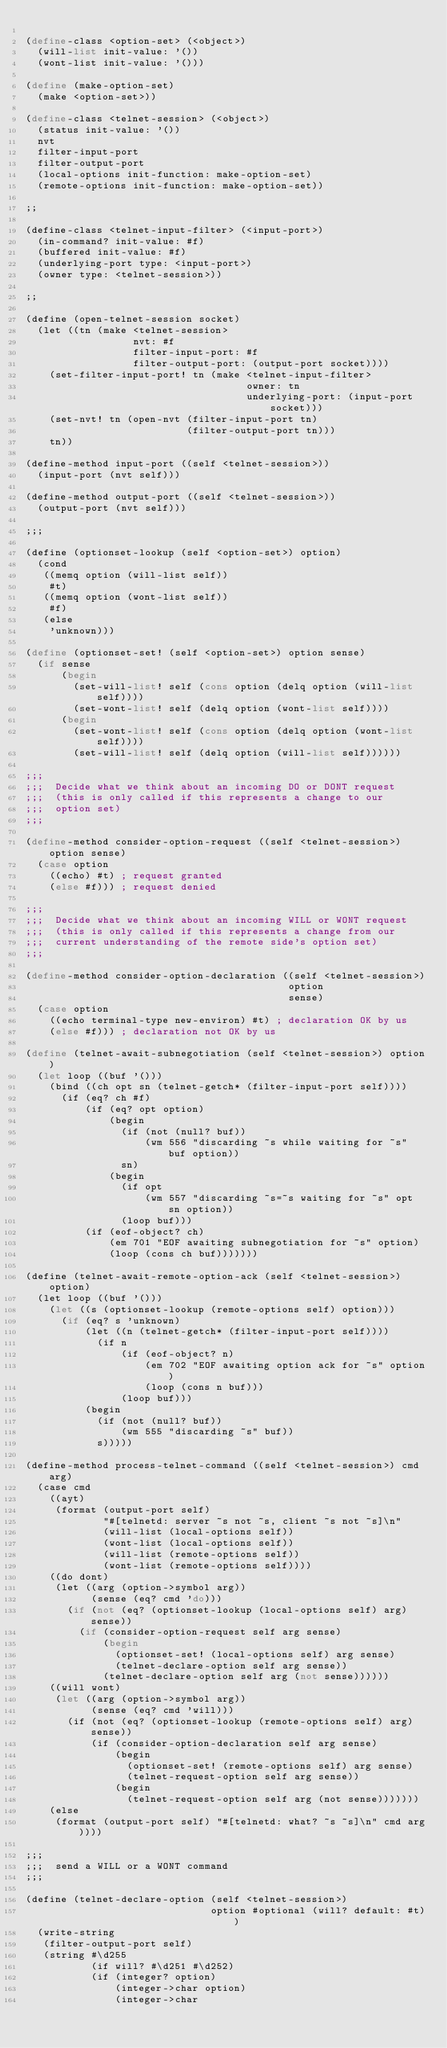Convert code to text. <code><loc_0><loc_0><loc_500><loc_500><_Scheme_>
(define-class <option-set> (<object>)
  (will-list init-value: '())
  (wont-list init-value: '()))

(define (make-option-set)
  (make <option-set>))

(define-class <telnet-session> (<object>)
  (status init-value: '())
  nvt
  filter-input-port
  filter-output-port
  (local-options init-function: make-option-set)
  (remote-options init-function: make-option-set))

;;

(define-class <telnet-input-filter> (<input-port>)
  (in-command? init-value: #f)
  (buffered init-value: #f)
  (underlying-port type: <input-port>)
  (owner type: <telnet-session>))

;;

(define (open-telnet-session socket)
  (let ((tn (make <telnet-session>
                  nvt: #f
                  filter-input-port: #f
                  filter-output-port: (output-port socket))))
    (set-filter-input-port! tn (make <telnet-input-filter>
                                     owner: tn
                                     underlying-port: (input-port socket)))
    (set-nvt! tn (open-nvt (filter-input-port tn) 
                           (filter-output-port tn)))
    tn))

(define-method input-port ((self <telnet-session>))
  (input-port (nvt self)))

(define-method output-port ((self <telnet-session>))
  (output-port (nvt self)))

;;;

(define (optionset-lookup (self <option-set>) option)
  (cond
   ((memq option (will-list self))
    #t)
   ((memq option (wont-list self))
    #f)
   (else
    'unknown)))

(define (optionset-set! (self <option-set>) option sense)
  (if sense
      (begin
        (set-will-list! self (cons option (delq option (will-list self))))
        (set-wont-list! self (delq option (wont-list self))))
      (begin
        (set-wont-list! self (cons option (delq option (wont-list self))))
        (set-will-list! self (delq option (will-list self))))))

;;;
;;;  Decide what we think about an incoming DO or DONT request
;;;  (this is only called if this represents a change to our
;;;  option set)
;;;

(define-method consider-option-request ((self <telnet-session>) option sense)
  (case option
    ((echo) #t) ; request granted
    (else #f))) ; request denied

;;;
;;;  Decide what we think about an incoming WILL or WONT request
;;;  (this is only called if this represents a change from our
;;;  current understanding of the remote side's option set)
;;;

(define-method consider-option-declaration ((self <telnet-session>) 
                                            option 
                                            sense)
  (case option
    ((echo terminal-type new-environ) #t) ; declaration OK by us
    (else #f))) ; declaration not OK by us

(define (telnet-await-subnegotiation (self <telnet-session>) option)
  (let loop ((buf '()))
    (bind ((ch opt sn (telnet-getch* (filter-input-port self))))
      (if (eq? ch #f)
          (if (eq? opt option)
              (begin
                (if (not (null? buf))
                    (wm 556 "discarding ~s while waiting for ~s" buf option))
                sn)
              (begin
                (if opt
                    (wm 557 "discarding ~s=~s waiting for ~s" opt sn option))
                (loop buf)))
          (if (eof-object? ch)
              (em 701 "EOF awaiting subnegotiation for ~s" option)
              (loop (cons ch buf)))))))
  
(define (telnet-await-remote-option-ack (self <telnet-session>) option)
  (let loop ((buf '()))
    (let ((s (optionset-lookup (remote-options self) option)))
      (if (eq? s 'unknown)
          (let ((n (telnet-getch* (filter-input-port self))))
            (if n
                (if (eof-object? n)
                    (em 702 "EOF awaiting option ack for ~s" option)
                    (loop (cons n buf)))
                (loop buf)))
          (begin
            (if (not (null? buf))
                (wm 555 "discarding ~s" buf))
            s)))))

(define-method process-telnet-command ((self <telnet-session>) cmd arg)
  (case cmd
    ((ayt)
     (format (output-port self) 
             "#[telnetd: server ~s not ~s, client ~s not ~s]\n"
             (will-list (local-options self))
             (wont-list (local-options self))
             (will-list (remote-options self))
             (wont-list (remote-options self))))
    ((do dont)
     (let ((arg (option->symbol arg))
           (sense (eq? cmd 'do)))
       (if (not (eq? (optionset-lookup (local-options self) arg) sense))
         (if (consider-option-request self arg sense)
             (begin
               (optionset-set! (local-options self) arg sense)
               (telnet-declare-option self arg sense))
             (telnet-declare-option self arg (not sense))))))
    ((will wont)
     (let ((arg (option->symbol arg))
           (sense (eq? cmd 'will)))
       (if (not (eq? (optionset-lookup (remote-options self) arg) sense))
           (if (consider-option-declaration self arg sense)
               (begin
                 (optionset-set! (remote-options self) arg sense)
                 (telnet-request-option self arg sense))
               (begin
                 (telnet-request-option self arg (not sense)))))))
    (else
     (format (output-port self) "#[telnetd: what? ~s ~s]\n" cmd arg))))

;;;
;;;  send a WILL or a WONT command
;;;

(define (telnet-declare-option (self <telnet-session>) 
                               option #optional (will? default: #t))
  (write-string
   (filter-output-port self)
   (string #\d255 
           (if will? #\d251 #\d252) 
           (if (integer? option)
               (integer->char option)
               (integer->char </code> 